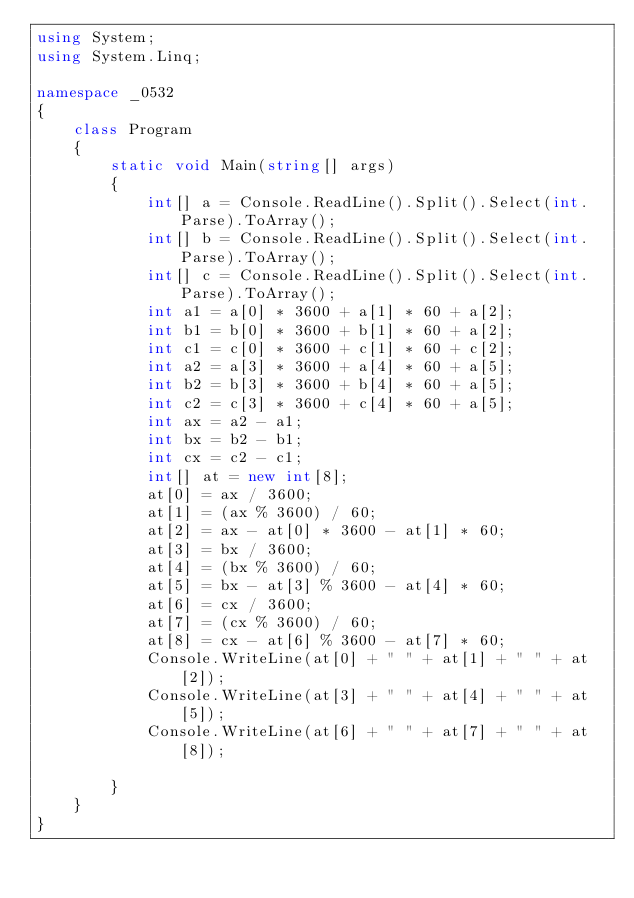Convert code to text. <code><loc_0><loc_0><loc_500><loc_500><_C#_>using System;
using System.Linq;

namespace _0532
{
    class Program
    {
        static void Main(string[] args)
        {
            int[] a = Console.ReadLine().Split().Select(int.Parse).ToArray();
            int[] b = Console.ReadLine().Split().Select(int.Parse).ToArray();
            int[] c = Console.ReadLine().Split().Select(int.Parse).ToArray();
            int a1 = a[0] * 3600 + a[1] * 60 + a[2];
            int b1 = b[0] * 3600 + b[1] * 60 + a[2];
            int c1 = c[0] * 3600 + c[1] * 60 + c[2];
            int a2 = a[3] * 3600 + a[4] * 60 + a[5];
            int b2 = b[3] * 3600 + b[4] * 60 + a[5];
            int c2 = c[3] * 3600 + c[4] * 60 + a[5];
            int ax = a2 - a1;
            int bx = b2 - b1;
            int cx = c2 - c1;
            int[] at = new int[8];
            at[0] = ax / 3600;
            at[1] = (ax % 3600) / 60;
            at[2] = ax - at[0] * 3600 - at[1] * 60;
            at[3] = bx / 3600;
            at[4] = (bx % 3600) / 60;
            at[5] = bx - at[3] % 3600 - at[4] * 60;
            at[6] = cx / 3600;
            at[7] = (cx % 3600) / 60;
            at[8] = cx - at[6] % 3600 - at[7] * 60;
            Console.WriteLine(at[0] + " " + at[1] + " " + at[2]);
            Console.WriteLine(at[3] + " " + at[4] + " " + at[5]);
            Console.WriteLine(at[6] + " " + at[7] + " " + at[8]);

        }
    }
}</code> 